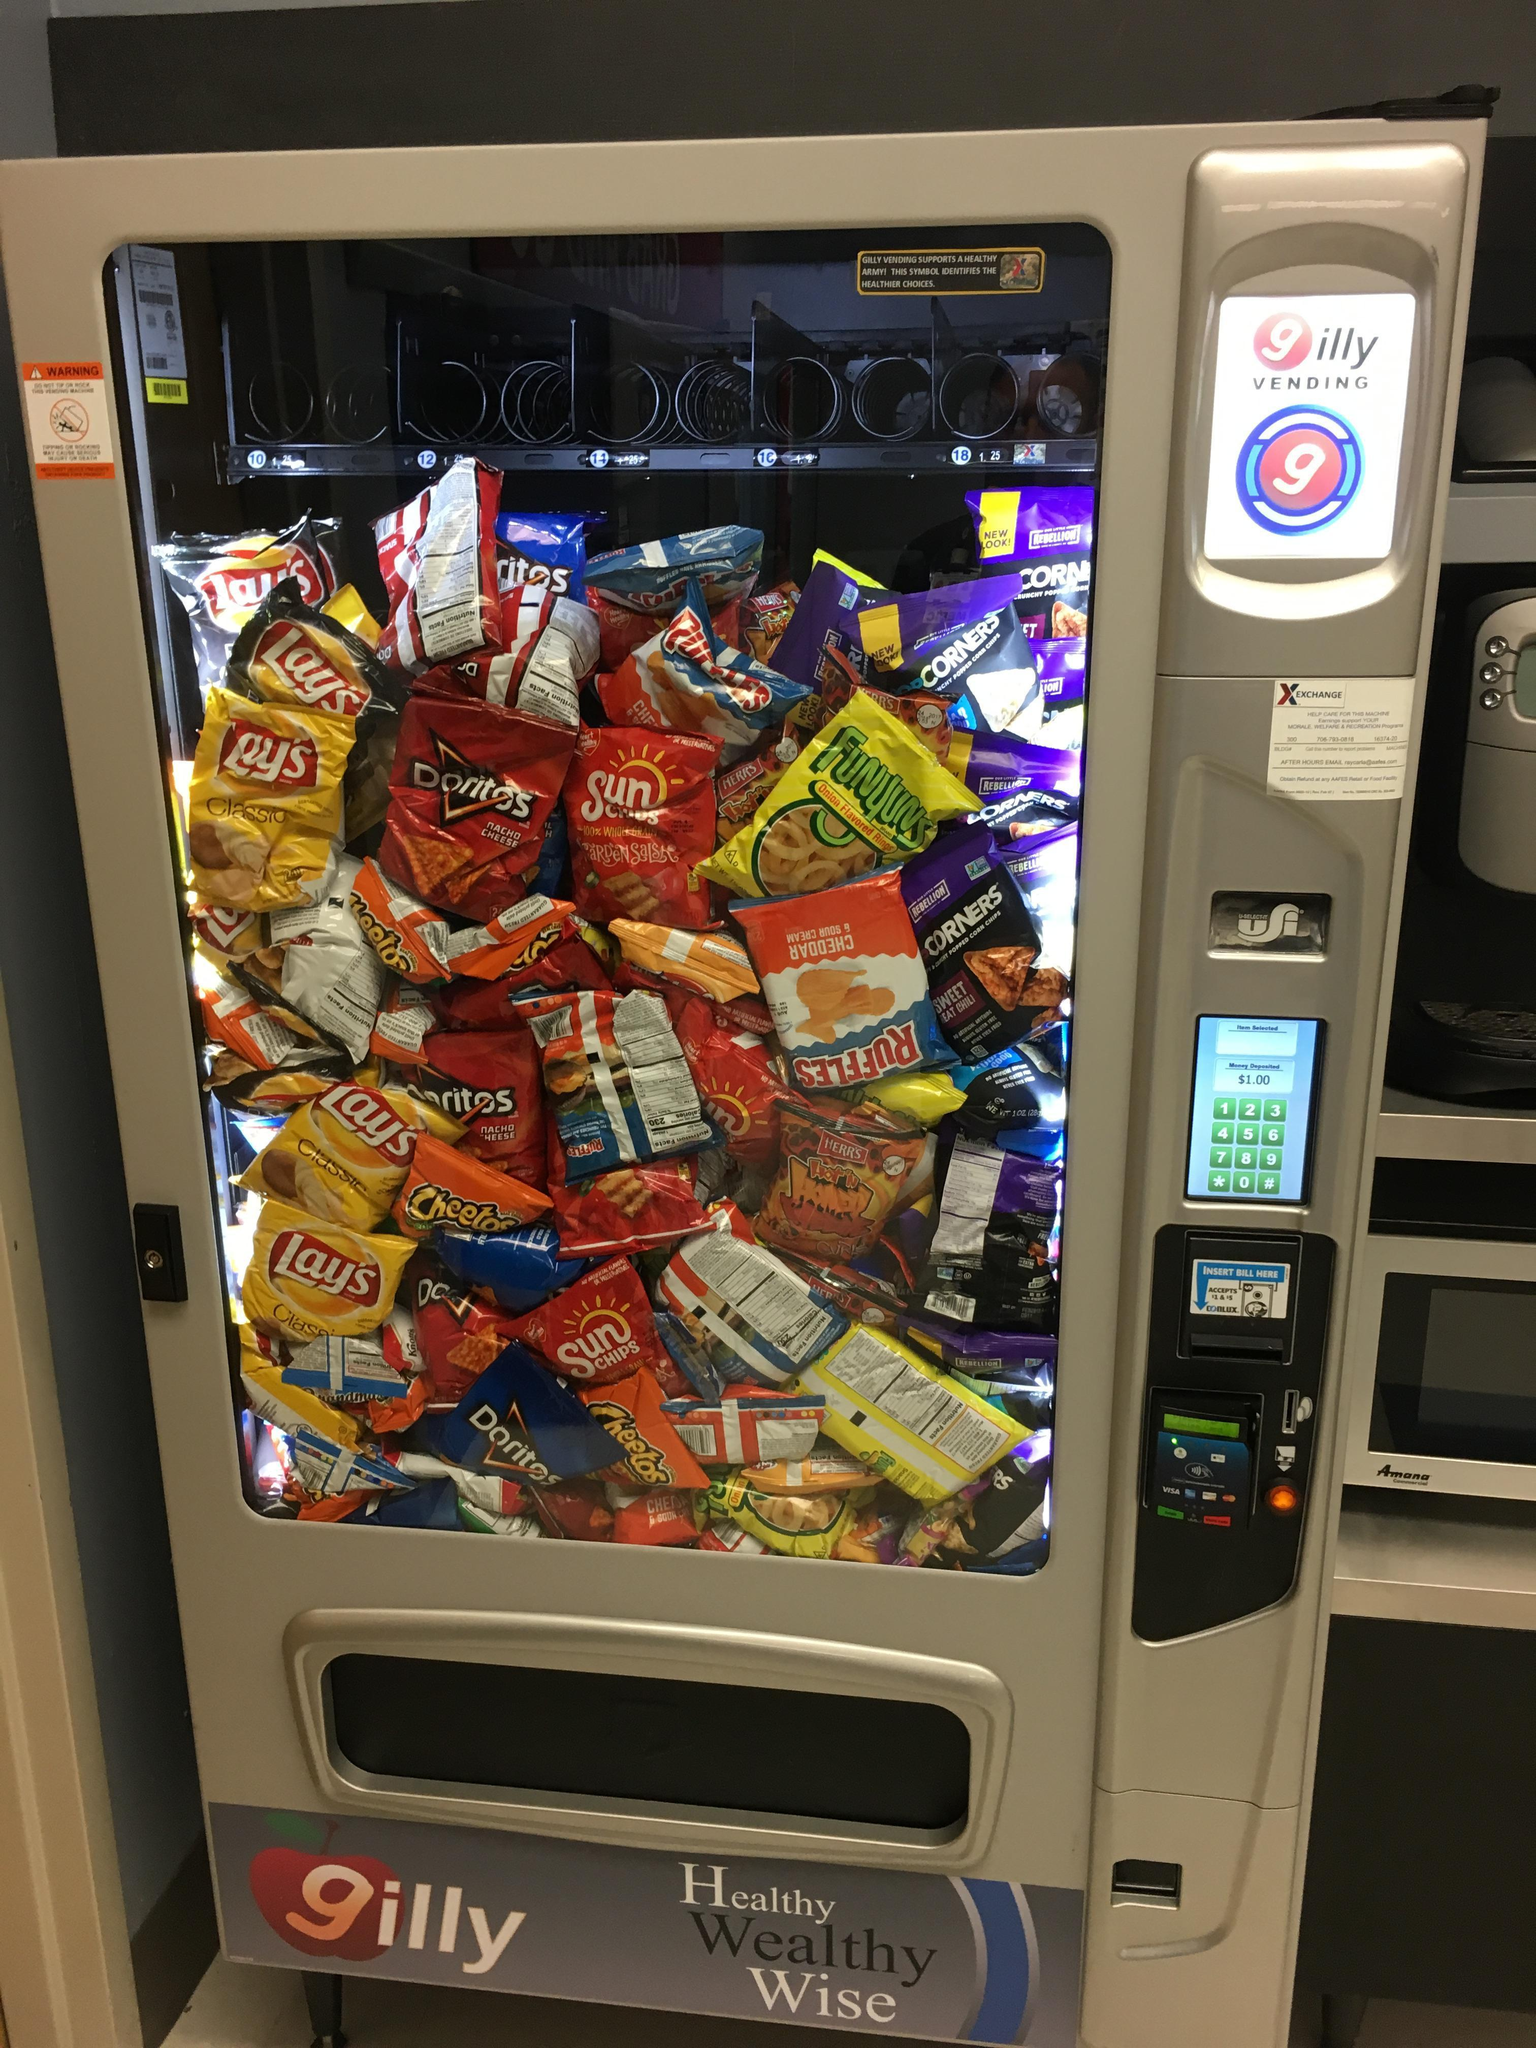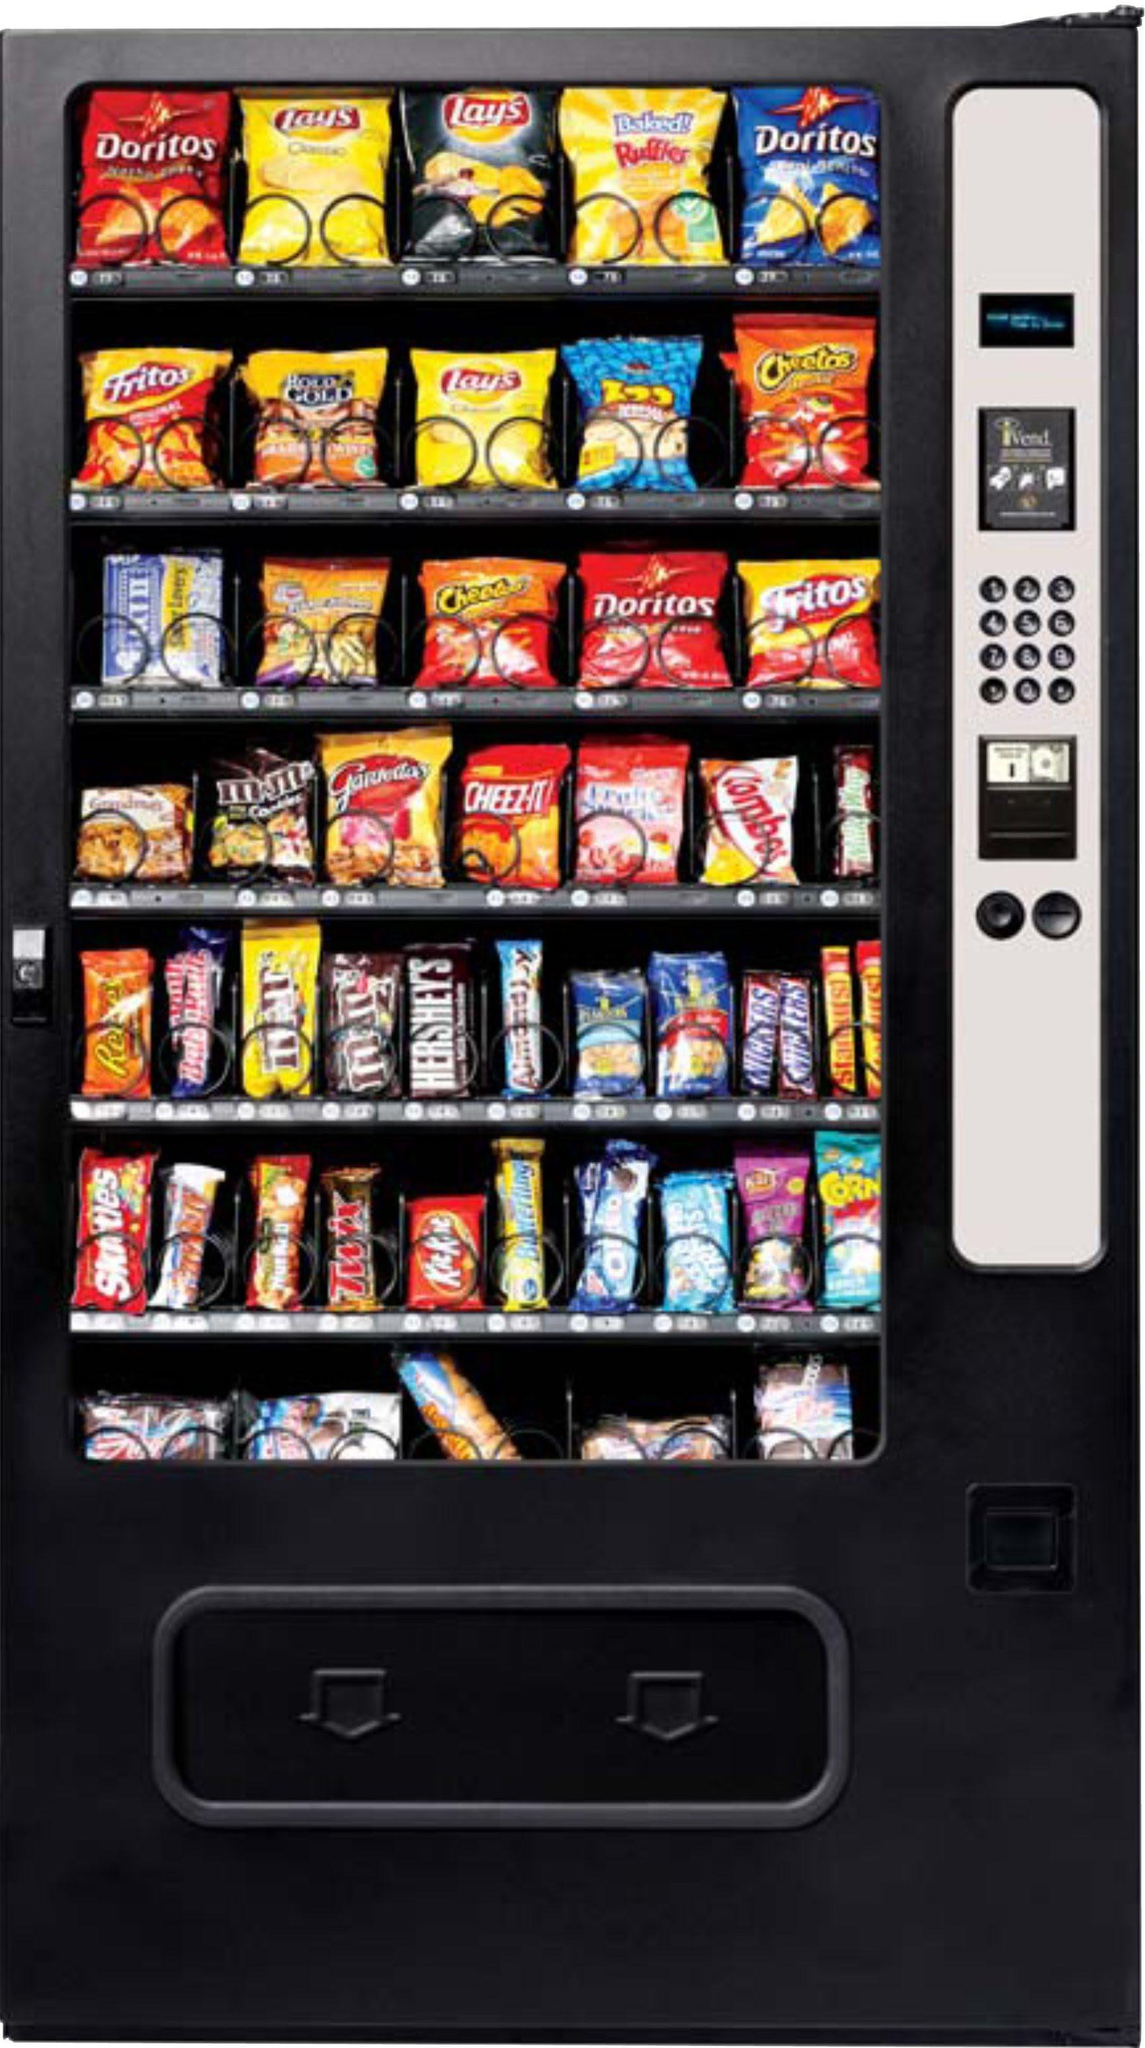The first image is the image on the left, the second image is the image on the right. Evaluate the accuracy of this statement regarding the images: "Exactly two vending machines filled with snacks are shown.". Is it true? Answer yes or no. Yes. 